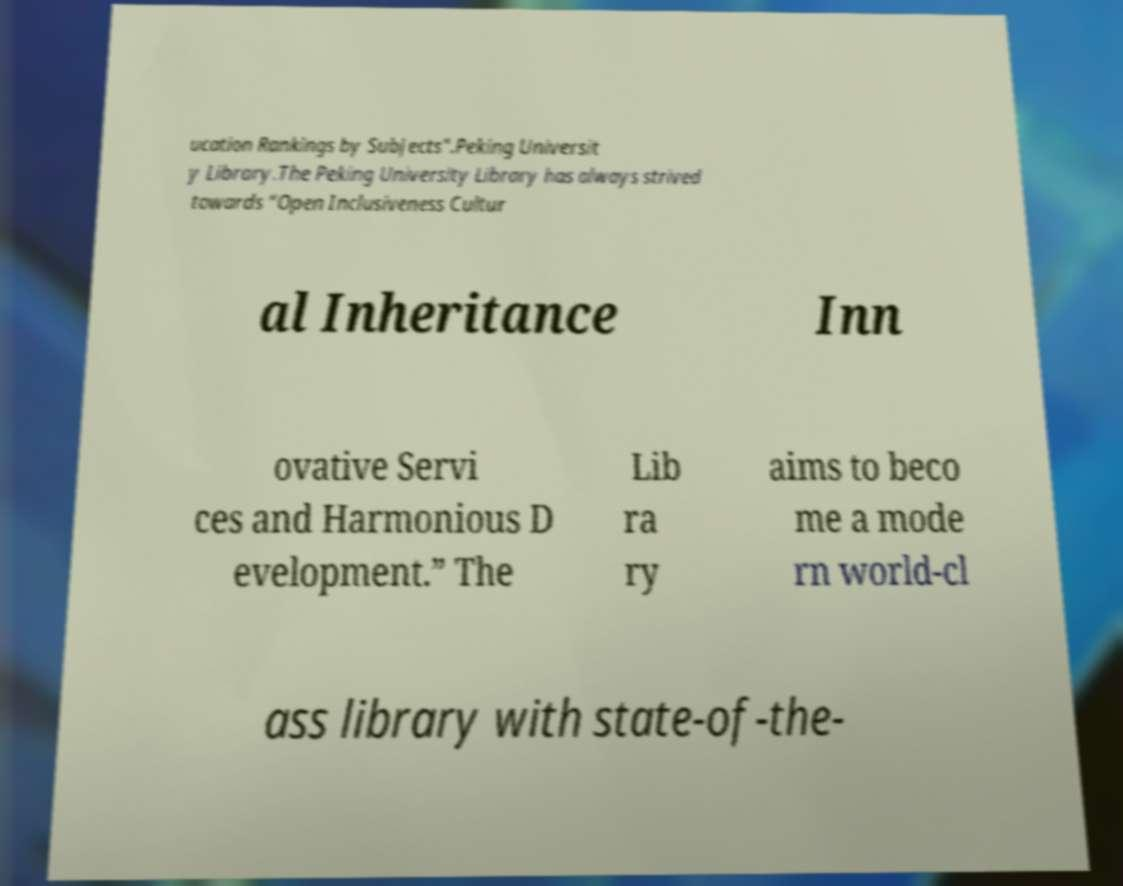What messages or text are displayed in this image? I need them in a readable, typed format. ucation Rankings by Subjects".Peking Universit y Library.The Peking University Library has always strived towards “Open Inclusiveness Cultur al Inheritance Inn ovative Servi ces and Harmonious D evelopment.” The Lib ra ry aims to beco me a mode rn world-cl ass library with state-of-the- 